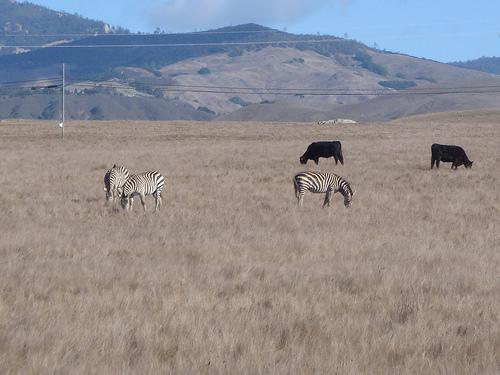Question: why was the picture taken?
Choices:
A. To capture the animals.
B. To test the camera.
C. To remember that vacation.
D. To show to someone else.
Answer with the letter. Answer: A Question: where was the picture taken?
Choices:
A. On a hill.
B. At the beach.
C. In a field.
D. On the roadside.
Answer with the letter. Answer: C Question: what are the animals doing?
Choices:
A. Sleeping.
B. Grazing.
C. Standing.
D. Running.
Answer with the letter. Answer: B Question: who can be seen with the animals?
Choices:
A. No one.
B. One person.
C. Two boys.
D. A girl.
Answer with the letter. Answer: A Question: how many animals are in the picture?
Choices:
A. Two.
B. Three.
C. Four.
D. Five.
Answer with the letter. Answer: D Question: what is in the horizon?
Choices:
A. Trees.
B. Buildings.
C. Hills.
D. Water.
Answer with the letter. Answer: C Question: when was the picture taken?
Choices:
A. Night time.
B. Dusk.
C. During the day.
D. Very early morning.
Answer with the letter. Answer: C 